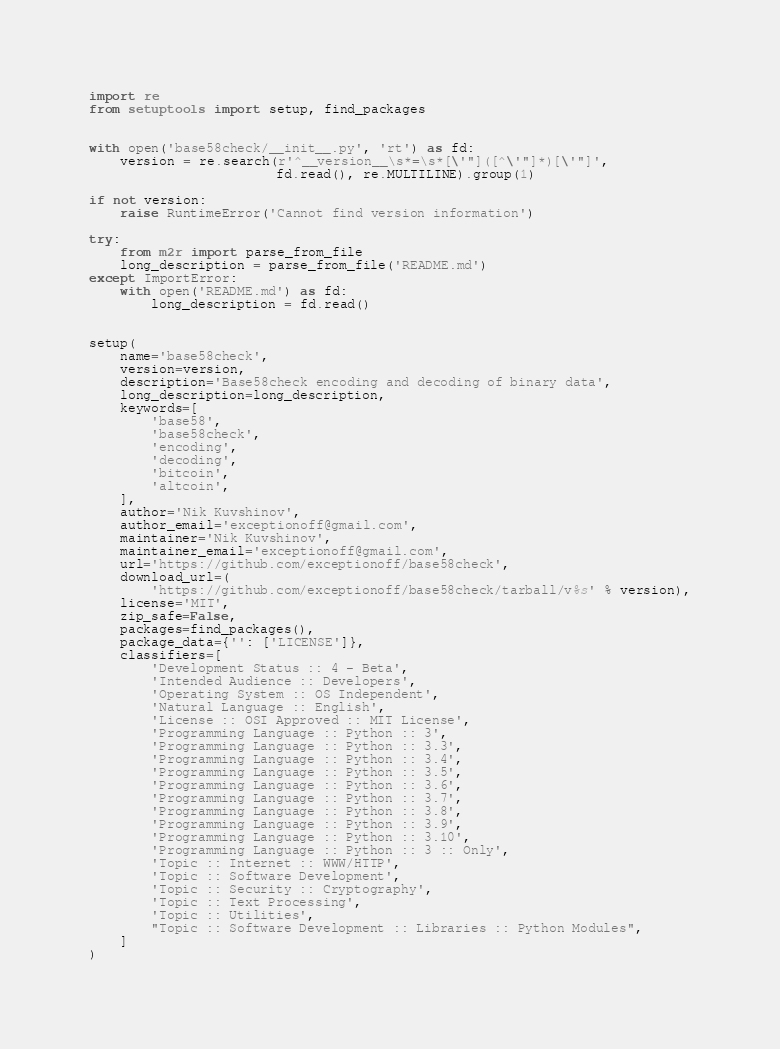<code> <loc_0><loc_0><loc_500><loc_500><_Python_>import re
from setuptools import setup, find_packages


with open('base58check/__init__.py', 'rt') as fd:
    version = re.search(r'^__version__\s*=\s*[\'"]([^\'"]*)[\'"]',
                        fd.read(), re.MULTILINE).group(1)

if not version:
    raise RuntimeError('Cannot find version information')

try:
    from m2r import parse_from_file
    long_description = parse_from_file('README.md')
except ImportError:
    with open('README.md') as fd:
        long_description = fd.read()


setup(
    name='base58check',
    version=version,
    description='Base58check encoding and decoding of binary data',
    long_description=long_description,
    keywords=[
        'base58',
        'base58check',
        'encoding',
        'decoding',
        'bitcoin',
        'altcoin',
    ],
    author='Nik Kuvshinov',
    author_email='exceptionoff@gmail.com',
    maintainer='Nik Kuvshinov',
    maintainer_email='exceptionoff@gmail.com',
    url='https://github.com/exceptionoff/base58check',
    download_url=(
        'https://github.com/exceptionoff/base58check/tarball/v%s' % version),
    license='MIT',
    zip_safe=False,
    packages=find_packages(),
    package_data={'': ['LICENSE']},
    classifiers=[
        'Development Status :: 4 - Beta',
        'Intended Audience :: Developers',
        'Operating System :: OS Independent',
        'Natural Language :: English',
        'License :: OSI Approved :: MIT License',
        'Programming Language :: Python :: 3',
        'Programming Language :: Python :: 3.3',
        'Programming Language :: Python :: 3.4',
        'Programming Language :: Python :: 3.5',
        'Programming Language :: Python :: 3.6',
        'Programming Language :: Python :: 3.7',
        'Programming Language :: Python :: 3.8',
        'Programming Language :: Python :: 3.9',
        'Programming Language :: Python :: 3.10',
        'Programming Language :: Python :: 3 :: Only',
        'Topic :: Internet :: WWW/HTTP',
        'Topic :: Software Development',
        'Topic :: Security :: Cryptography',
        'Topic :: Text Processing',
        'Topic :: Utilities',
        "Topic :: Software Development :: Libraries :: Python Modules",
    ]
)
</code> 